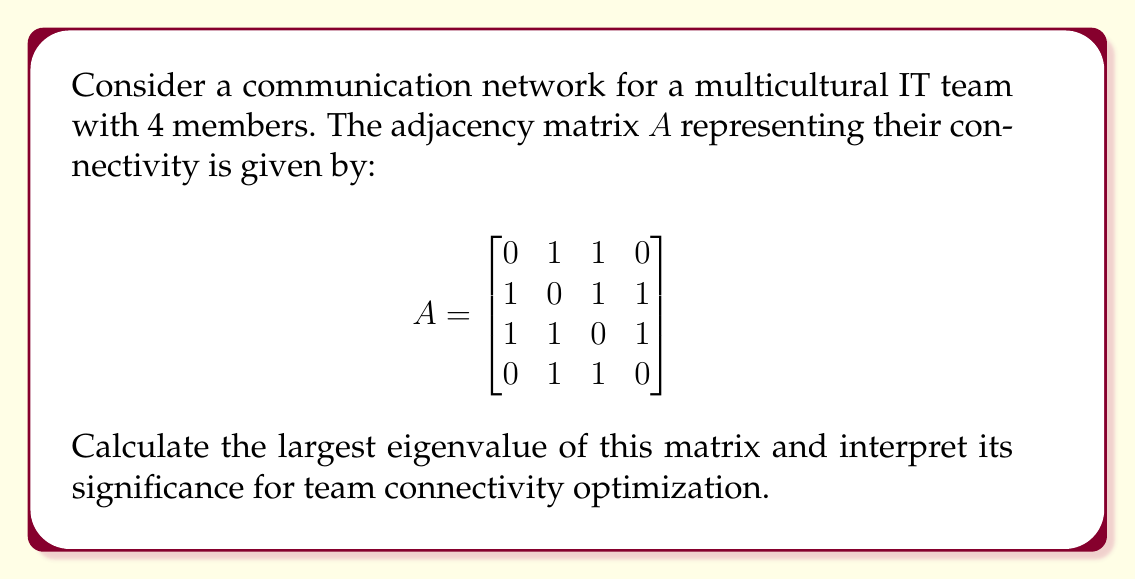Can you solve this math problem? To find the largest eigenvalue of the adjacency matrix $A$, we'll follow these steps:

1) First, we need to find the characteristic polynomial of $A$:
   $det(A - \lambda I) = 0$

2) Expanding the determinant:
   $$\begin{vmatrix}
   -\lambda & 1 & 1 & 0 \\
   1 & -\lambda & 1 & 1 \\
   1 & 1 & -\lambda & 1 \\
   0 & 1 & 1 & -\lambda
   \end{vmatrix} = 0$$

3) Calculating the determinant:
   $\lambda^4 - 6\lambda^2 - 4\lambda + 1 = 0$

4) This polynomial is difficult to solve analytically, so we'll use numerical methods or a computer algebra system to find the roots.

5) The roots (eigenvalues) are approximately:
   $\lambda_1 \approx 2.4812$
   $\lambda_2 \approx 0.3111$
   $\lambda_3 \approx -1.3962$
   $\lambda_4 \approx -1.3962$

6) The largest eigenvalue is $\lambda_1 \approx 2.4812$.

Interpretation:
The largest eigenvalue, also known as the spectral radius, is a measure of the network's connectivity. In the context of team communication:

- A larger value indicates better overall connectivity in the network.
- For this team, the value of 2.4812 suggests a moderate to good level of connectivity.
- To optimize team connectivity, the project manager should aim to increase this value by encouraging more connections between team members.
- The theoretical maximum for a 4-node network is 3, so there's room for improvement in team communication.
Answer: $\lambda_{max} \approx 2.4812$, indicating moderate to good team connectivity with potential for improvement. 